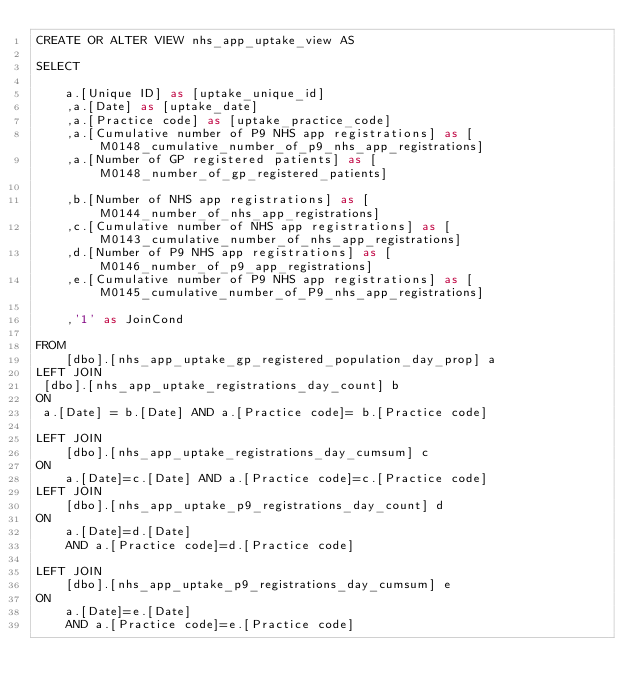Convert code to text. <code><loc_0><loc_0><loc_500><loc_500><_SQL_>CREATE OR ALTER VIEW nhs_app_uptake_view AS 

SELECT

    a.[Unique ID] as [uptake_unique_id]
    ,a.[Date] as [uptake_date]
    ,a.[Practice code] as [uptake_practice_code]	
    ,a.[Cumulative number of P9 NHS app registrations] as [M0148_cumulative_number_of_p9_nhs_app_registrations]
    ,a.[Number of GP registered patients] as [M0148_number_of_gp_registered_patients]

    ,b.[Number of NHS app registrations] as [M0144_number_of_nhs_app_registrations]
    ,c.[Cumulative number of NHS app registrations] as [M0143_cumulative_number_of_nhs_app_registrations]
    ,d.[Number of P9 NHS app registrations] as [M0146_number_of_p9_app_registrations]
    ,e.[Cumulative number of P9 NHS app registrations] as [M0145_cumulative_number_of_P9_nhs_app_registrations]
 
    ,'1' as JoinCond

FROM
    [dbo].[nhs_app_uptake_gp_registered_population_day_prop] a
LEFT JOIN
 [dbo].[nhs_app_uptake_registrations_day_count] b
ON
 a.[Date] = b.[Date] AND a.[Practice code]= b.[Practice code]

LEFT JOIN
    [dbo].[nhs_app_uptake_registrations_day_cumsum] c
ON
    a.[Date]=c.[Date] AND a.[Practice code]=c.[Practice code]
LEFT JOIN
    [dbo].[nhs_app_uptake_p9_registrations_day_count] d
ON
    a.[Date]=d.[Date]
    AND a.[Practice code]=d.[Practice code]

LEFT JOIN
    [dbo].[nhs_app_uptake_p9_registrations_day_cumsum] e
ON
    a.[Date]=e.[Date]
    AND a.[Practice code]=e.[Practice code]
</code> 